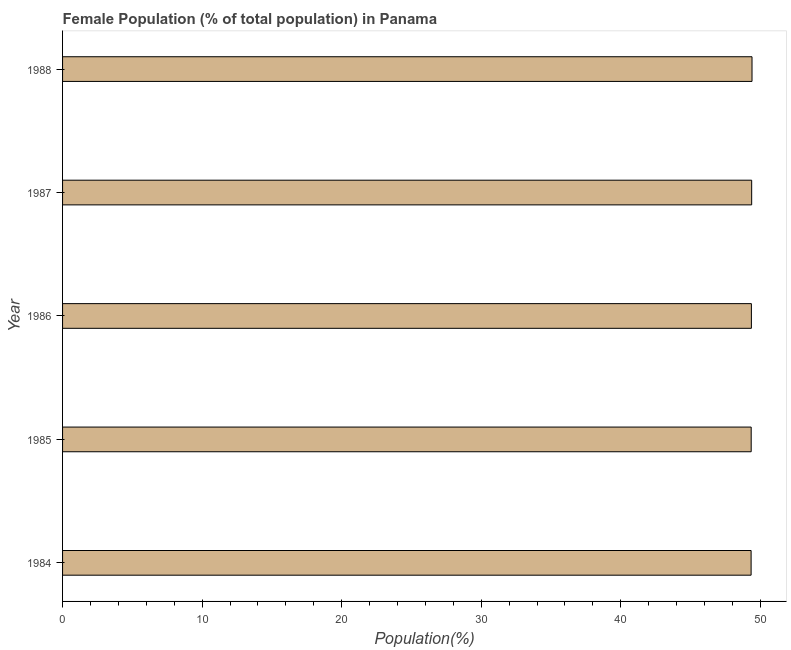Does the graph contain any zero values?
Offer a very short reply. No. Does the graph contain grids?
Offer a very short reply. No. What is the title of the graph?
Offer a very short reply. Female Population (% of total population) in Panama. What is the label or title of the X-axis?
Provide a short and direct response. Population(%). What is the label or title of the Y-axis?
Ensure brevity in your answer.  Year. What is the female population in 1984?
Provide a succinct answer. 49.34. Across all years, what is the maximum female population?
Make the answer very short. 49.4. Across all years, what is the minimum female population?
Give a very brief answer. 49.34. In which year was the female population maximum?
Your answer should be very brief. 1988. What is the sum of the female population?
Offer a terse response. 246.83. What is the difference between the female population in 1985 and 1986?
Provide a succinct answer. -0.01. What is the average female population per year?
Give a very brief answer. 49.37. What is the median female population?
Give a very brief answer. 49.36. What is the ratio of the female population in 1985 to that in 1986?
Ensure brevity in your answer.  1. Is the difference between the female population in 1984 and 1985 greater than the difference between any two years?
Give a very brief answer. No. What is the difference between the highest and the second highest female population?
Your answer should be compact. 0.02. What is the difference between the highest and the lowest female population?
Offer a very short reply. 0.07. How many years are there in the graph?
Provide a short and direct response. 5. Are the values on the major ticks of X-axis written in scientific E-notation?
Keep it short and to the point. No. What is the Population(%) in 1984?
Offer a terse response. 49.34. What is the Population(%) of 1985?
Make the answer very short. 49.35. What is the Population(%) of 1986?
Keep it short and to the point. 49.36. What is the Population(%) in 1987?
Provide a short and direct response. 49.38. What is the Population(%) in 1988?
Your answer should be very brief. 49.4. What is the difference between the Population(%) in 1984 and 1985?
Your answer should be very brief. -0.01. What is the difference between the Population(%) in 1984 and 1986?
Your answer should be compact. -0.02. What is the difference between the Population(%) in 1984 and 1987?
Give a very brief answer. -0.04. What is the difference between the Population(%) in 1984 and 1988?
Your answer should be compact. -0.07. What is the difference between the Population(%) in 1985 and 1986?
Provide a short and direct response. -0.01. What is the difference between the Population(%) in 1985 and 1987?
Provide a succinct answer. -0.03. What is the difference between the Population(%) in 1985 and 1988?
Ensure brevity in your answer.  -0.06. What is the difference between the Population(%) in 1986 and 1987?
Ensure brevity in your answer.  -0.02. What is the difference between the Population(%) in 1986 and 1988?
Give a very brief answer. -0.04. What is the difference between the Population(%) in 1987 and 1988?
Ensure brevity in your answer.  -0.02. What is the ratio of the Population(%) in 1984 to that in 1985?
Your answer should be very brief. 1. What is the ratio of the Population(%) in 1984 to that in 1986?
Your answer should be very brief. 1. What is the ratio of the Population(%) in 1984 to that in 1987?
Offer a very short reply. 1. What is the ratio of the Population(%) in 1984 to that in 1988?
Your answer should be compact. 1. What is the ratio of the Population(%) in 1985 to that in 1986?
Ensure brevity in your answer.  1. 